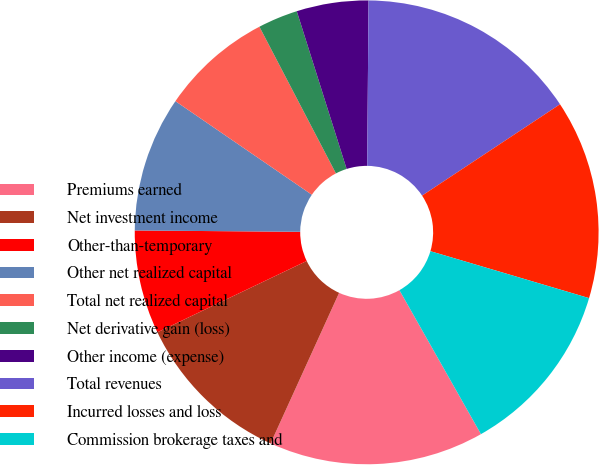<chart> <loc_0><loc_0><loc_500><loc_500><pie_chart><fcel>Premiums earned<fcel>Net investment income<fcel>Other-than-temporary<fcel>Other net realized capital<fcel>Total net realized capital<fcel>Net derivative gain (loss)<fcel>Other income (expense)<fcel>Total revenues<fcel>Incurred losses and loss<fcel>Commission brokerage taxes and<nl><fcel>15.0%<fcel>11.11%<fcel>7.22%<fcel>9.44%<fcel>7.78%<fcel>2.78%<fcel>5.0%<fcel>15.56%<fcel>13.89%<fcel>12.22%<nl></chart> 